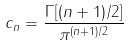Convert formula to latex. <formula><loc_0><loc_0><loc_500><loc_500>c _ { n } = \frac { \Gamma [ ( n + 1 ) / 2 ] } { \pi ^ { ( n + 1 ) / 2 } }</formula> 